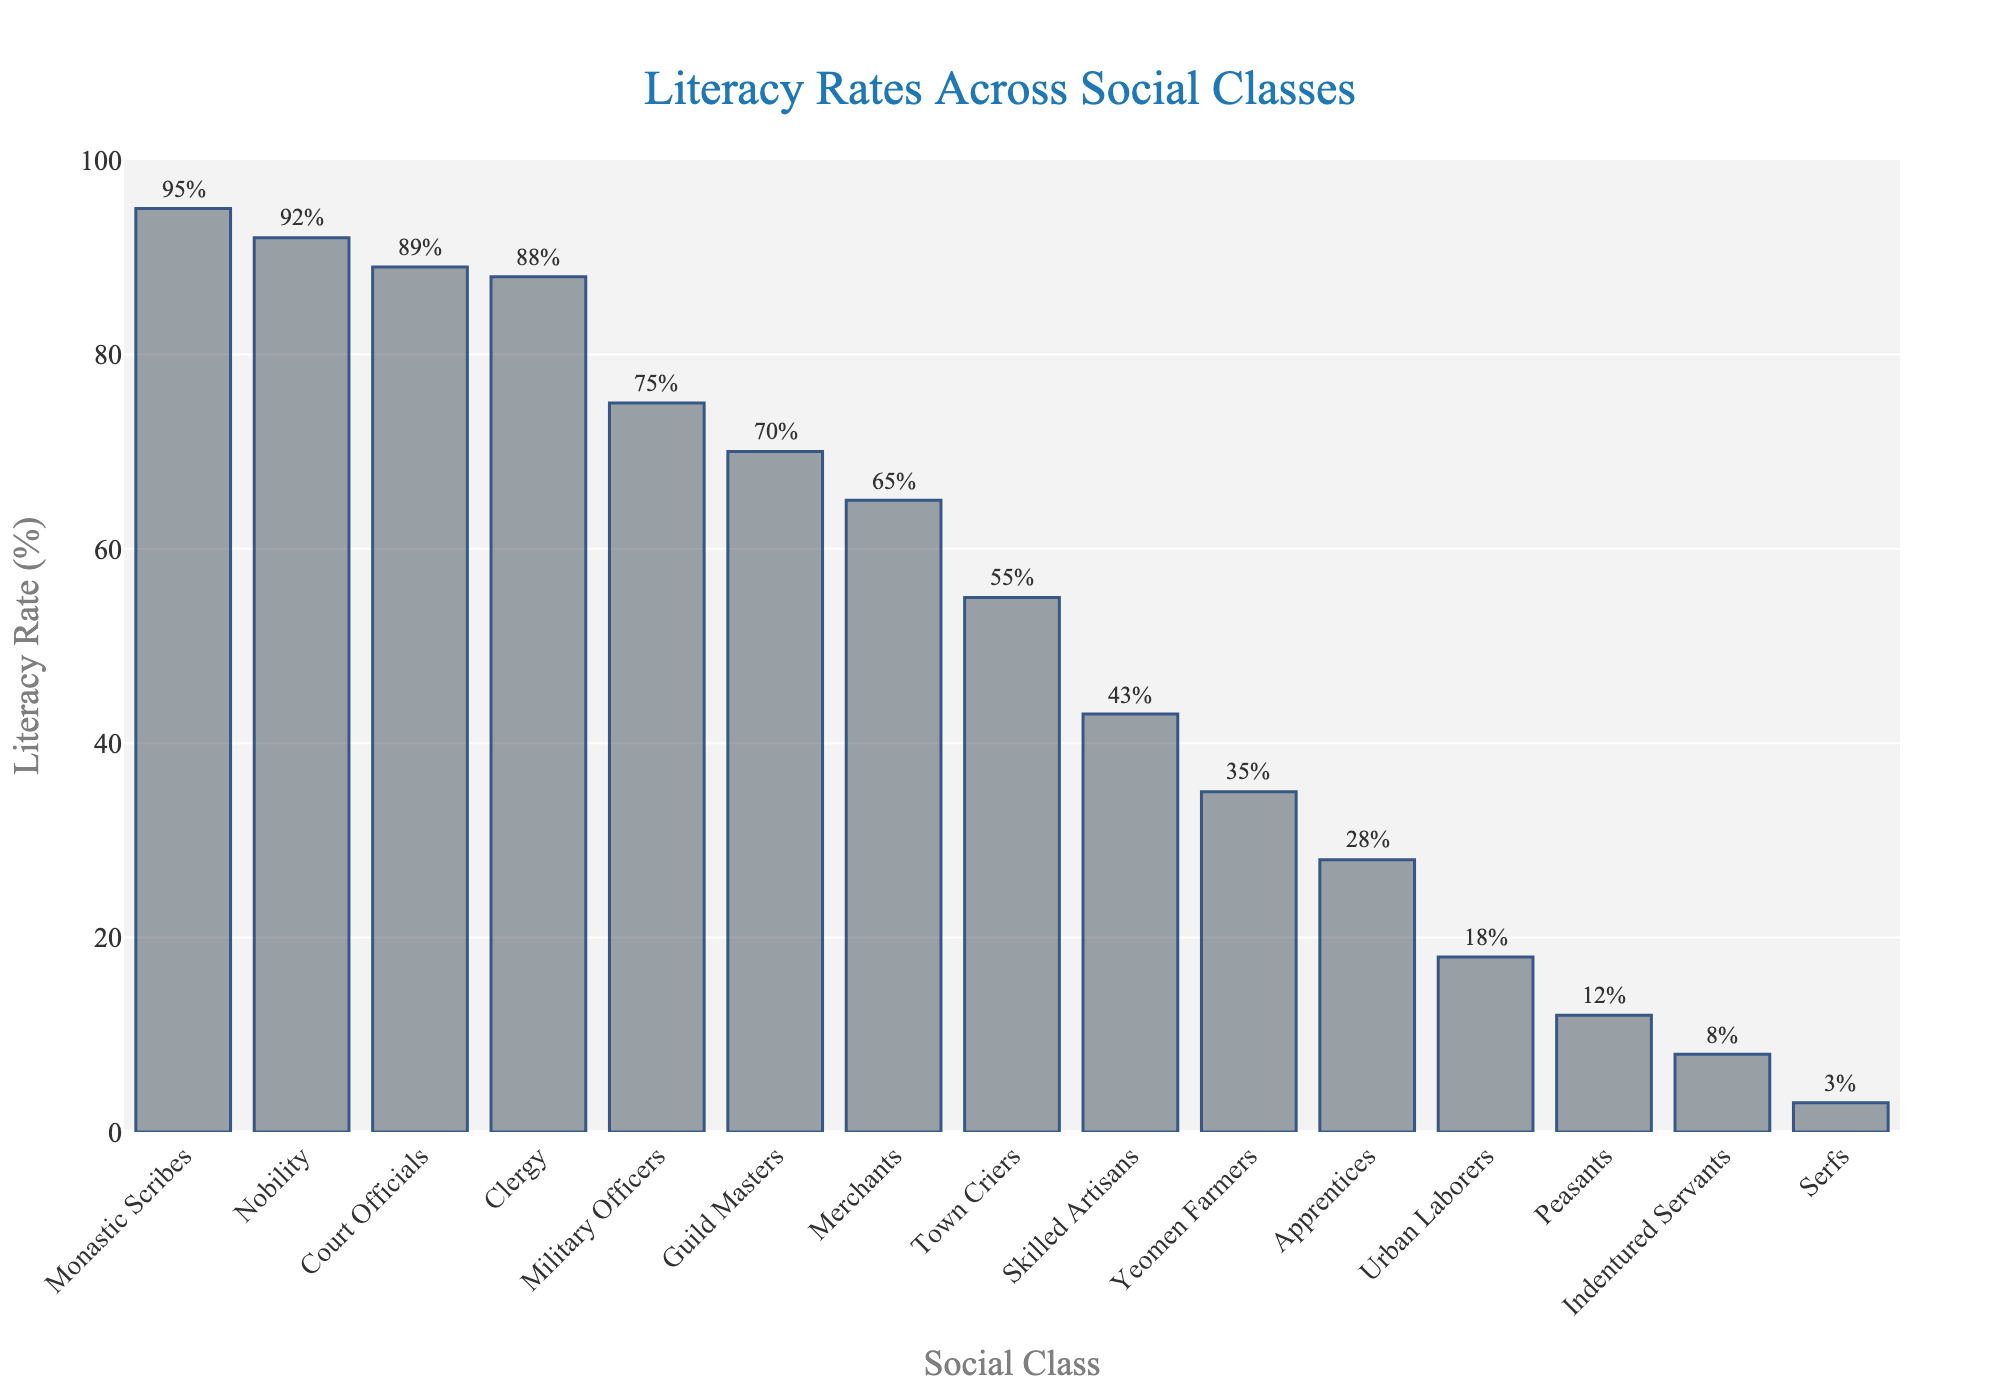What's the difference in literacy rates between Nobility and Serfs? To solve this, subtract the literacy rate of Serfs from that of the Nobility. The literacy rate for Nobility is 92%, and for Serfs, it is 3%. Therefore, 92% - 3% = 89%.
Answer: 89% What is the average literacy rate of Merchants, Skilled Artisans, and Yeomen Farmers? First, find the literacy rates: Merchants (65%), Skilled Artisans (43%), and Yeomen Farmers (35%). Add these percentages together: 65 + 43 + 35 = 143. Then, divide by 3 to find the average: 143 / 3 = 47.67%.
Answer: 47.67% Which social class has a higher literacy rate, Military Officers or Guild Masters? The literacy rate for Military Officers is 75%, while for Guild Masters it is 70%. Since 75% > 70%, Military Officers have a higher literacy rate.
Answer: Military Officers What is the combined literacy rate of Clergy and Court Officials? Add the literacy rates of Clergy (88%) and Court Officials (89%) together: 88 + 89 = 177%.
Answer: 177% Rank the top three social classes based on their literacy rates. Observing the bar heights, the top three social classes in descending order of literacy rates are: Monastic Scribes (95%), Nobility (92%), and Court Officials (89%).
Answer: Monastic Scribes, Nobility, Court Officials How much greater is the literacy rate of Clergy compared to Peasants? Subtract the literacy rate of Peasants (12%) from that of Clergy (88%): 88% - 12% = 76%.
Answer: 76% Which social class has the lowest literacy rate, and what is it? The lowest literacy rate is for Serfs, at 3%.
Answer: Serfs If the literacy rate of Apprentices increases by 10%, what would their new literacy rate be? The current literacy rate for Apprentices is 28%. If it increases by 10%, the new rate would be 28% + 10% = 38%.
Answer: 38% Is the literacy rate of Town Criers more similar to that of Merchants or Urban Laborers? The literacy rate of Town Criers is 55%. Merchants have a literacy rate of 65%, and Urban Laborers have a literacy rate of 18%. The difference between Town Criers and Merchants is 65% - 55% = 10%. The difference between Town Criers and Urban Laborers is 55% - 18% = 37%. Therefore, Town Criers are more similar to Merchants.
Answer: Merchants What percentage of the literacy rate of Nobility is the literacy rate of Indentured Servants? The literacy rate of Nobility is 92%, and that of Indentured Servants is 8%. To find the percentage, use the formula (8 / 92) * 100 = 8.70%.
Answer: 8.70% 